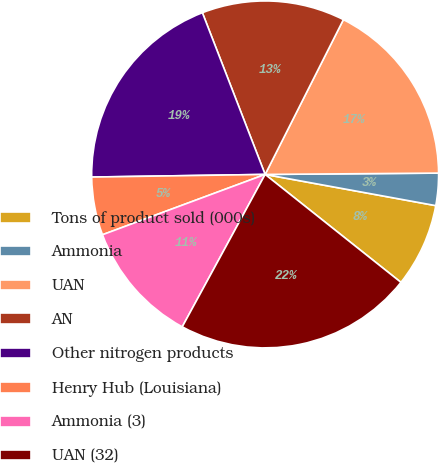<chart> <loc_0><loc_0><loc_500><loc_500><pie_chart><fcel>Tons of product sold (000s)<fcel>Ammonia<fcel>UAN<fcel>AN<fcel>Other nitrogen products<fcel>Henry Hub (Louisiana)<fcel>Ammonia (3)<fcel>UAN (32)<nl><fcel>7.81%<fcel>3.0%<fcel>17.43%<fcel>13.34%<fcel>19.35%<fcel>5.41%<fcel>11.42%<fcel>22.24%<nl></chart> 